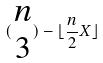<formula> <loc_0><loc_0><loc_500><loc_500>( \begin{matrix} n \\ 3 \end{matrix} ) - \lfloor \frac { n } { 2 } X \rfloor</formula> 